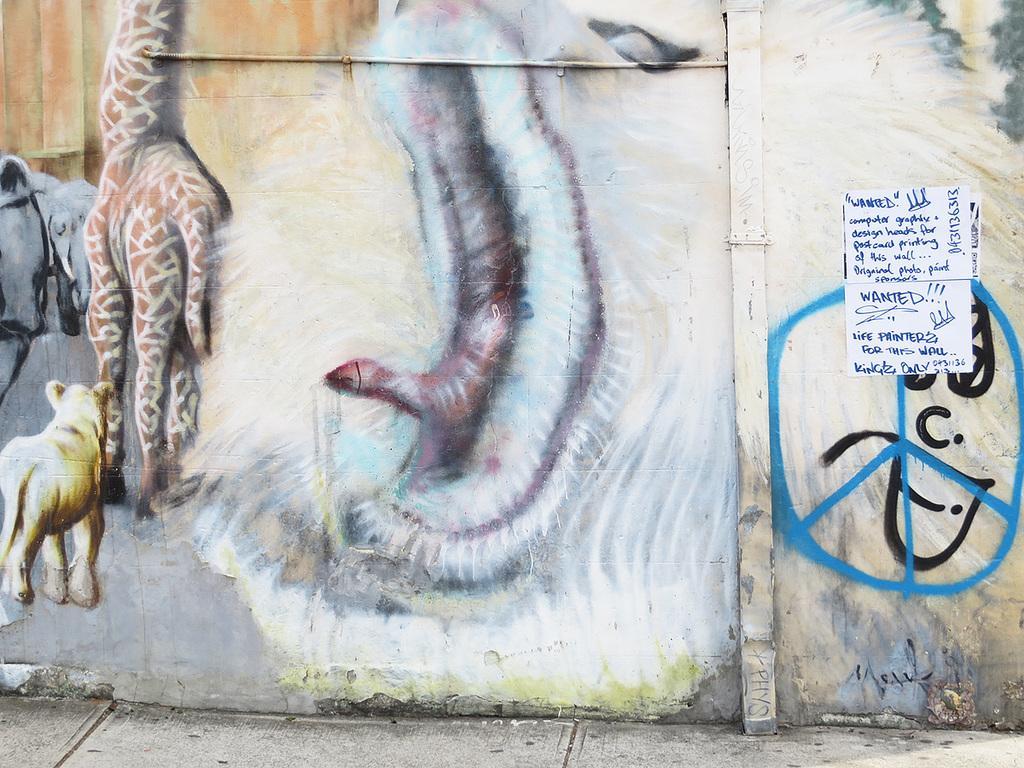In one or two sentences, can you explain what this image depicts? In this image we can see an art of animals painted on the wall. Here we can see a poster on which we can see some text is written. 